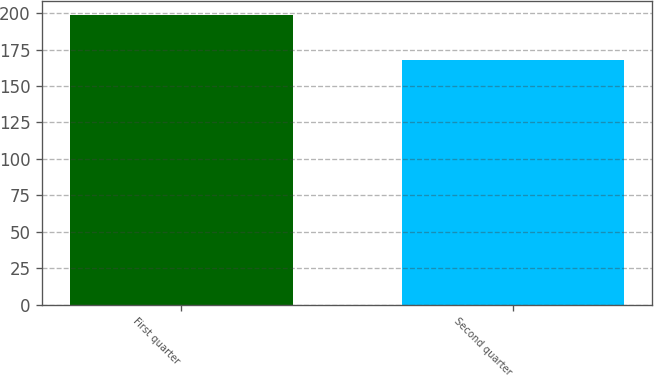Convert chart to OTSL. <chart><loc_0><loc_0><loc_500><loc_500><bar_chart><fcel>First quarter<fcel>Second quarter<nl><fcel>198.42<fcel>167.92<nl></chart> 